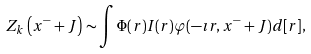<formula> <loc_0><loc_0><loc_500><loc_500>Z _ { k } \left ( x ^ { - } + J \right ) \sim \int \Phi ( r ) I ( r ) \varphi ( - \imath r , x ^ { - } + J ) d [ r ] ,</formula> 